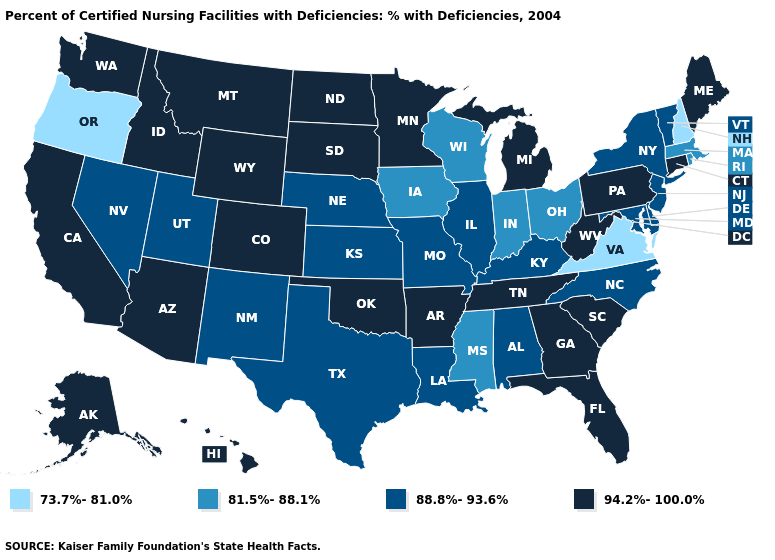What is the value of South Carolina?
Quick response, please. 94.2%-100.0%. Name the states that have a value in the range 73.7%-81.0%?
Keep it brief. New Hampshire, Oregon, Virginia. Is the legend a continuous bar?
Keep it brief. No. Among the states that border North Dakota , which have the lowest value?
Concise answer only. Minnesota, Montana, South Dakota. Which states have the lowest value in the USA?
Concise answer only. New Hampshire, Oregon, Virginia. What is the highest value in states that border Pennsylvania?
Answer briefly. 94.2%-100.0%. Does Connecticut have a higher value than Vermont?
Answer briefly. Yes. What is the lowest value in the Northeast?
Give a very brief answer. 73.7%-81.0%. Does Connecticut have a higher value than Colorado?
Short answer required. No. Name the states that have a value in the range 73.7%-81.0%?
Answer briefly. New Hampshire, Oregon, Virginia. Name the states that have a value in the range 81.5%-88.1%?
Quick response, please. Indiana, Iowa, Massachusetts, Mississippi, Ohio, Rhode Island, Wisconsin. Does Arkansas have the highest value in the South?
Keep it brief. Yes. Name the states that have a value in the range 81.5%-88.1%?
Short answer required. Indiana, Iowa, Massachusetts, Mississippi, Ohio, Rhode Island, Wisconsin. What is the value of Connecticut?
Short answer required. 94.2%-100.0%. What is the lowest value in the USA?
Give a very brief answer. 73.7%-81.0%. 